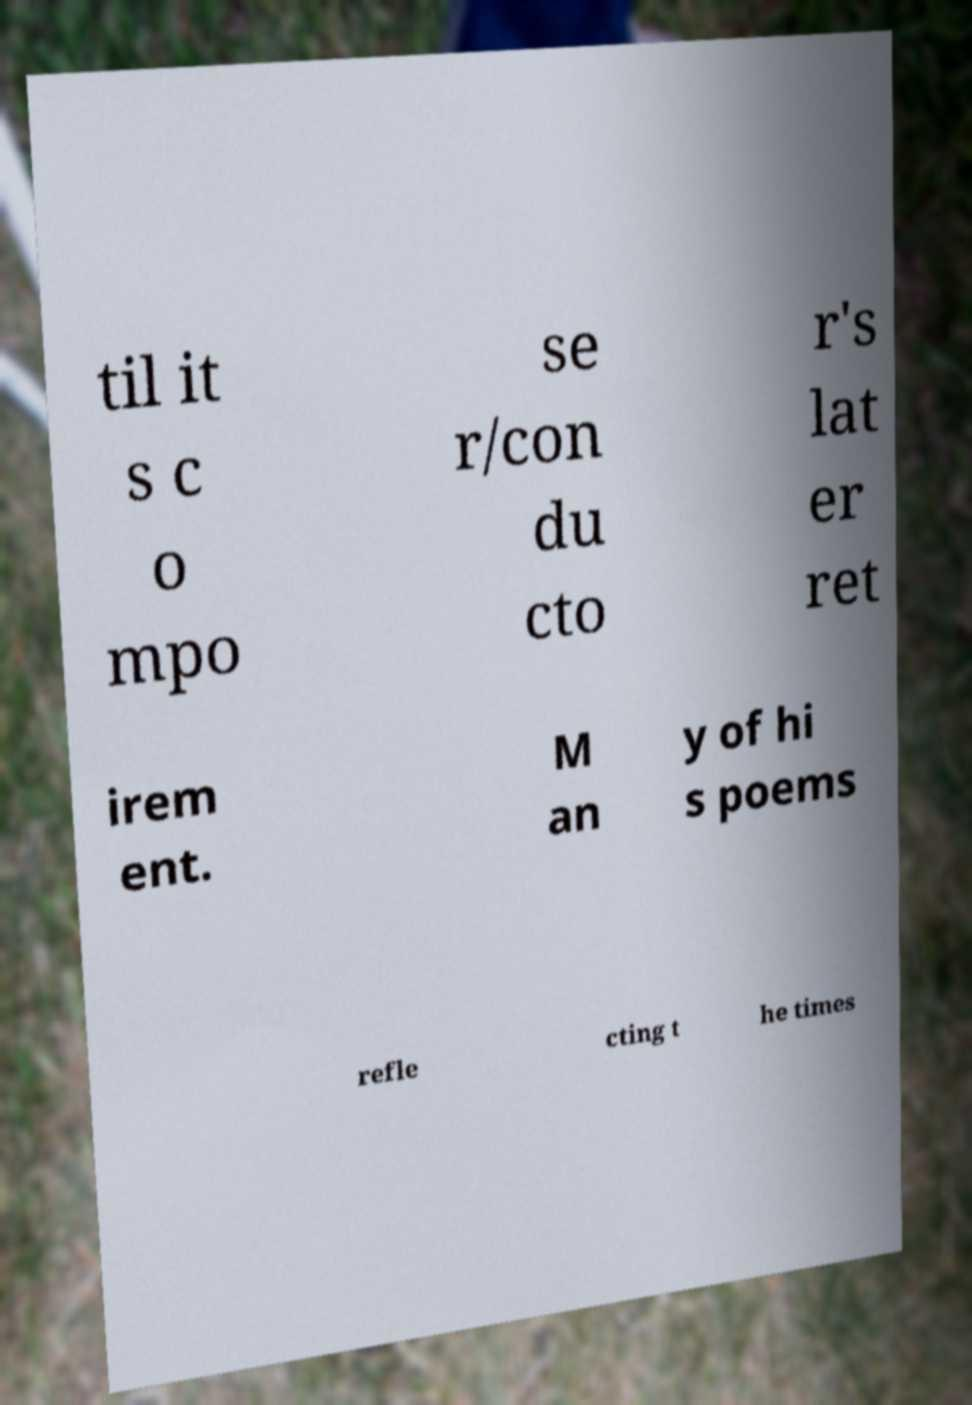There's text embedded in this image that I need extracted. Can you transcribe it verbatim? til it s c o mpo se r/con du cto r's lat er ret irem ent. M an y of hi s poems refle cting t he times 